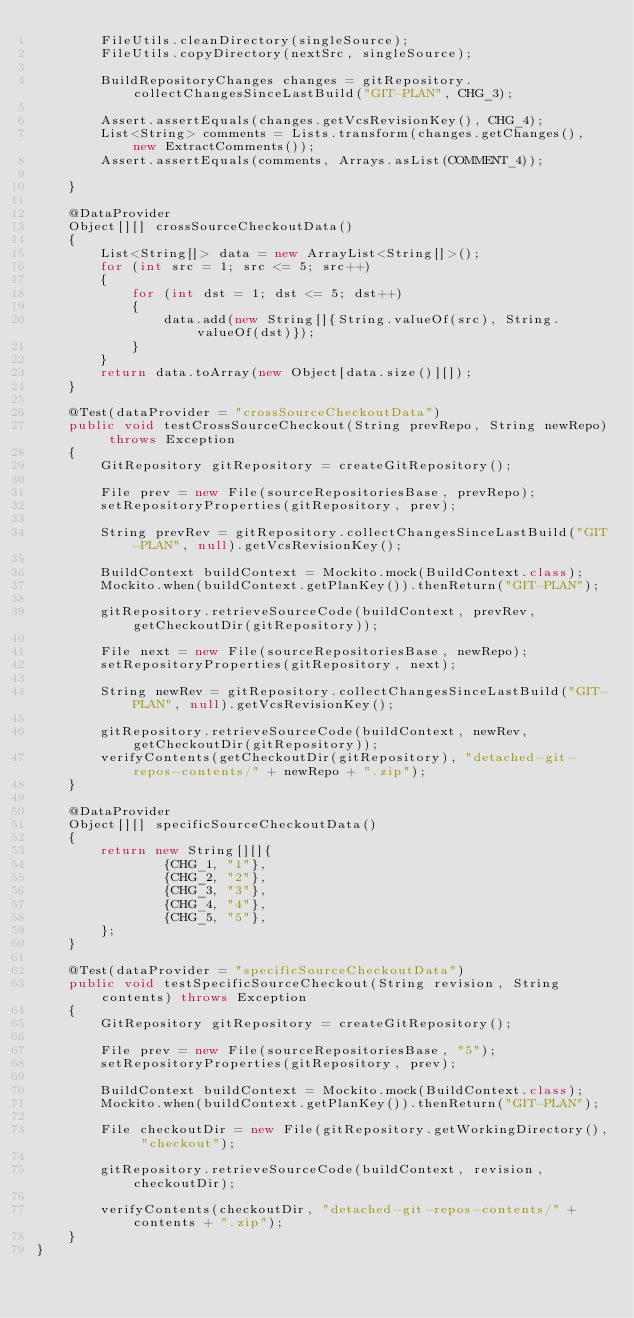<code> <loc_0><loc_0><loc_500><loc_500><_Java_>        FileUtils.cleanDirectory(singleSource);
        FileUtils.copyDirectory(nextSrc, singleSource);

        BuildRepositoryChanges changes = gitRepository.collectChangesSinceLastBuild("GIT-PLAN", CHG_3);

        Assert.assertEquals(changes.getVcsRevisionKey(), CHG_4);
        List<String> comments = Lists.transform(changes.getChanges(), new ExtractComments());
        Assert.assertEquals(comments, Arrays.asList(COMMENT_4));

    }

    @DataProvider
    Object[][] crossSourceCheckoutData()
    {
        List<String[]> data = new ArrayList<String[]>();
        for (int src = 1; src <= 5; src++)
        {
            for (int dst = 1; dst <= 5; dst++)
            {
                data.add(new String[]{String.valueOf(src), String.valueOf(dst)});
            }
        }
        return data.toArray(new Object[data.size()][]);
    }

    @Test(dataProvider = "crossSourceCheckoutData")
    public void testCrossSourceCheckout(String prevRepo, String newRepo) throws Exception
    {
        GitRepository gitRepository = createGitRepository();

        File prev = new File(sourceRepositoriesBase, prevRepo);
        setRepositoryProperties(gitRepository, prev);

        String prevRev = gitRepository.collectChangesSinceLastBuild("GIT-PLAN", null).getVcsRevisionKey();

        BuildContext buildContext = Mockito.mock(BuildContext.class);
        Mockito.when(buildContext.getPlanKey()).thenReturn("GIT-PLAN");

        gitRepository.retrieveSourceCode(buildContext, prevRev, getCheckoutDir(gitRepository));

        File next = new File(sourceRepositoriesBase, newRepo);
        setRepositoryProperties(gitRepository, next);

        String newRev = gitRepository.collectChangesSinceLastBuild("GIT-PLAN", null).getVcsRevisionKey();

        gitRepository.retrieveSourceCode(buildContext, newRev, getCheckoutDir(gitRepository));
        verifyContents(getCheckoutDir(gitRepository), "detached-git-repos-contents/" + newRepo + ".zip");
    }

    @DataProvider
    Object[][] specificSourceCheckoutData()
    {
        return new String[][]{
                {CHG_1, "1"},
                {CHG_2, "2"},
                {CHG_3, "3"},
                {CHG_4, "4"},
                {CHG_5, "5"},
        };
    }

    @Test(dataProvider = "specificSourceCheckoutData")
    public void testSpecificSourceCheckout(String revision, String contents) throws Exception
    {
        GitRepository gitRepository = createGitRepository();

        File prev = new File(sourceRepositoriesBase, "5");
        setRepositoryProperties(gitRepository, prev);

        BuildContext buildContext = Mockito.mock(BuildContext.class);
        Mockito.when(buildContext.getPlanKey()).thenReturn("GIT-PLAN");

        File checkoutDir = new File(gitRepository.getWorkingDirectory(), "checkout");

        gitRepository.retrieveSourceCode(buildContext, revision, checkoutDir);

        verifyContents(checkoutDir, "detached-git-repos-contents/" + contents + ".zip");
    }
}
</code> 